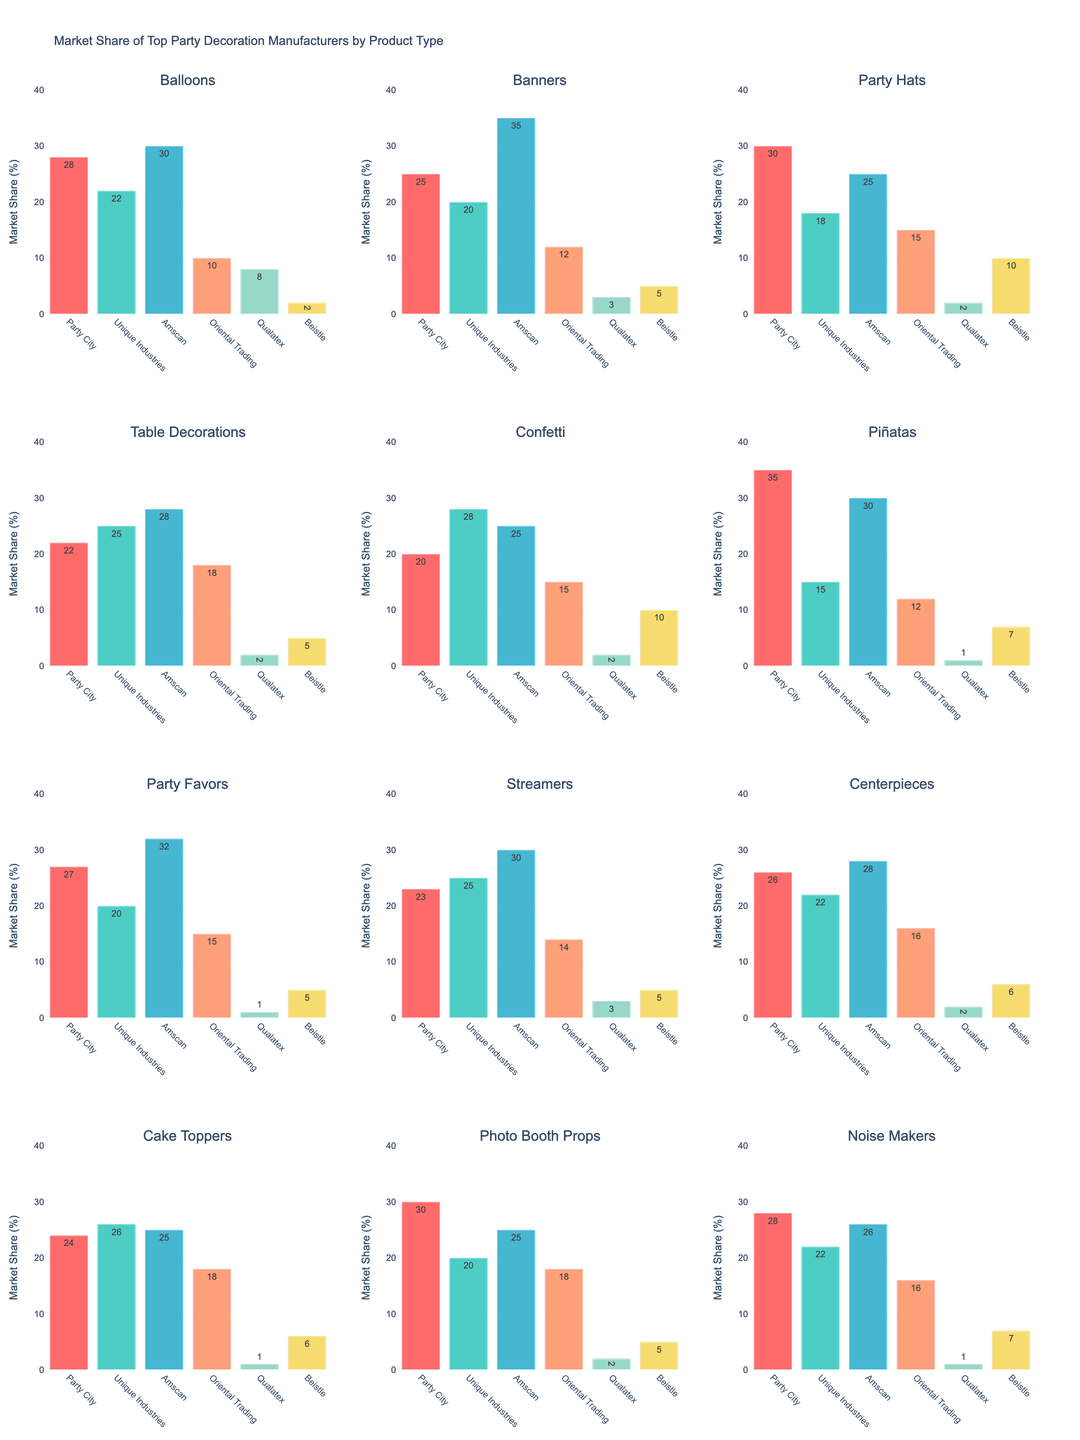Which manufacturer has the highest market share for Balloons? Look at the subplot for Balloons and compare the heights of the bars. The tallest bar represents Amscan with a market share of 30%.
Answer: Amscan What is the total market share for Party Hats between the top two manufacturers? Look at the subplot for Party Hats and identify the top two manufacturers (Party City with 30% and Amscan with 25%). Sum their market shares: 30% + 25% = 55%.
Answer: 55% Which product type has the highest market share for Party City? Examine each subplot and find the product type where the Party City bar is the highest. Party Hats have a market share of 30%, which is the highest among all product types for Party City.
Answer: Party Hats Compare the market share of Unique Industries and Oriental Trading for Table Decorations. Which has a greater share and by how much? In the subplot for Table Decorations, Unique Industries has a share of 25%, and Oriental Trading has 18%. The difference is 25% - 18% = 7%. Unique Industries has a greater share by 7%.
Answer: Unique Industries, 7% What is the average market share of Beistle across all product types? Sum the market share values for Beistle across all product types: (2 + 5 + 10 + 5 + 10 + 7 + 5 + 5 + 6 + 6 + 5 + 7) = 73. There are 12 product types, so the average is 73 / 12 ≈ 6.08%.
Answer: 6.08% How does the market share of Qualatex in Piñatas compare to its market share in Banners? In the subplot for Piñatas, Qualatex has a market share of 1%. In the subplot for Banners, Qualatex has a market share of 3%. Therefore, Qualatex's market share in Banners is greater by 2%.
Answer: Banners, 2% Identify the product type with the smallest market share for Oriental Trading. Examine each subplot and find the one where the bar for Oriental Trading is the shortest. Oriental Trading has the smallest market share for Balloons and Piñatas, both with 12%.
Answer: Balloons and Piñatas, 12% Which manufacturer holds the second-highest market share for Cake Toppers? In the subplot for Cake Toppers, the second tallest bar belongs to Unique Industries with a share of 26%.
Answer: Unique Industries Calculate the median market share of Party City across all product types. List the market share values for Party City: (28, 25, 30, 22, 20, 35, 27, 23, 26, 24, 30, 28). Arrange them in ascending order: (20, 22, 23, 24, 25, 26, 27, 28, 28, 30, 30, 35). The median is the average of the 6th and 7th values: (26 + 27) / 2 = 26.5.
Answer: 26.5 In how many product types does Amscan have the highest market share? Inspect each subplot and identify how many times Amscan's bar is the tallest. Amscan has the highest market share in 5 product types: Balloons, Banners, Party Favors, Streamers, and Noise Makers.
Answer: 5 